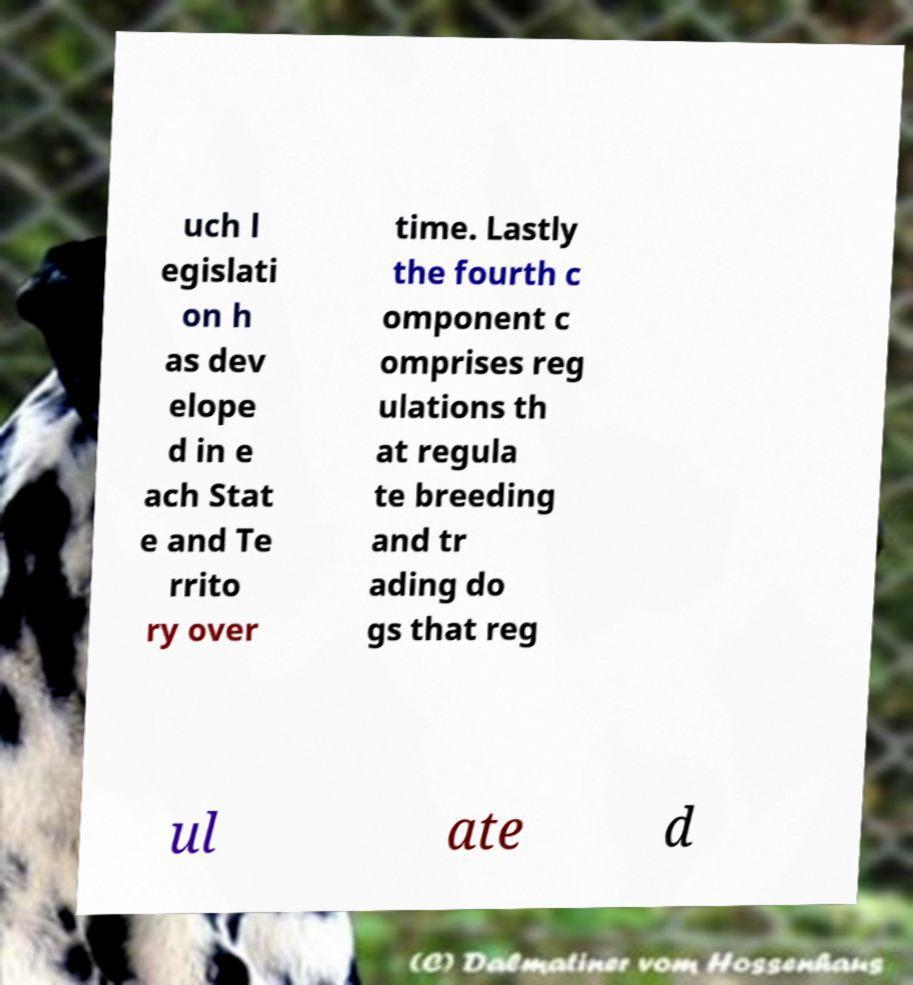Can you accurately transcribe the text from the provided image for me? uch l egislati on h as dev elope d in e ach Stat e and Te rrito ry over time. Lastly the fourth c omponent c omprises reg ulations th at regula te breeding and tr ading do gs that reg ul ate d 